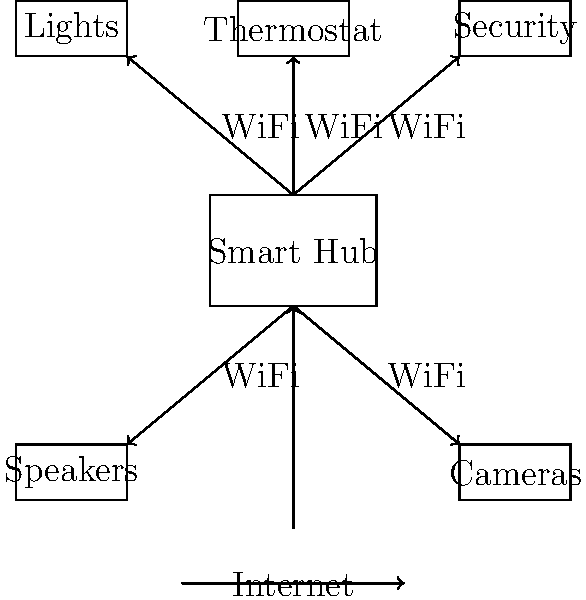In a typical Smart Home system architecture, what is the central component that connects and manages all the smart devices, and what communication protocol is commonly used for device connectivity? To answer this question, let's break down the architecture of a typical Smart Home system:

1. Central Component:
   - The central component in a Smart Home system is typically called a Smart Hub or Home Controller.
   - It acts as the brain of the system, connecting and managing all smart devices.

2. Device Connectivity:
   - Smart devices (e.g., lights, thermostat, security systems, speakers, cameras) connect to the Smart Hub.
   - These devices communicate with the hub using various protocols, but WiFi is one of the most common.

3. Communication Protocol:
   - WiFi is widely used due to its ubiquity in modern homes and its ability to handle high-bandwidth data.
   - Other protocols like Zigbee, Z-Wave, or Bluetooth may also be used, but WiFi is the most prevalent.

4. Internet Connectivity:
   - The Smart Hub is usually connected to the internet, allowing for remote access and control.
   - This connection also enables integration with cloud services and voice assistants.

5. Device Management:
   - The Smart Hub coordinates communication between devices and can automate actions based on user preferences or schedules.

In the context of Fredericton, which has a growing tech scene, understanding Smart Home systems is particularly relevant for technology enthusiasts looking to optimize their living spaces.
Answer: Smart Hub; WiFi 